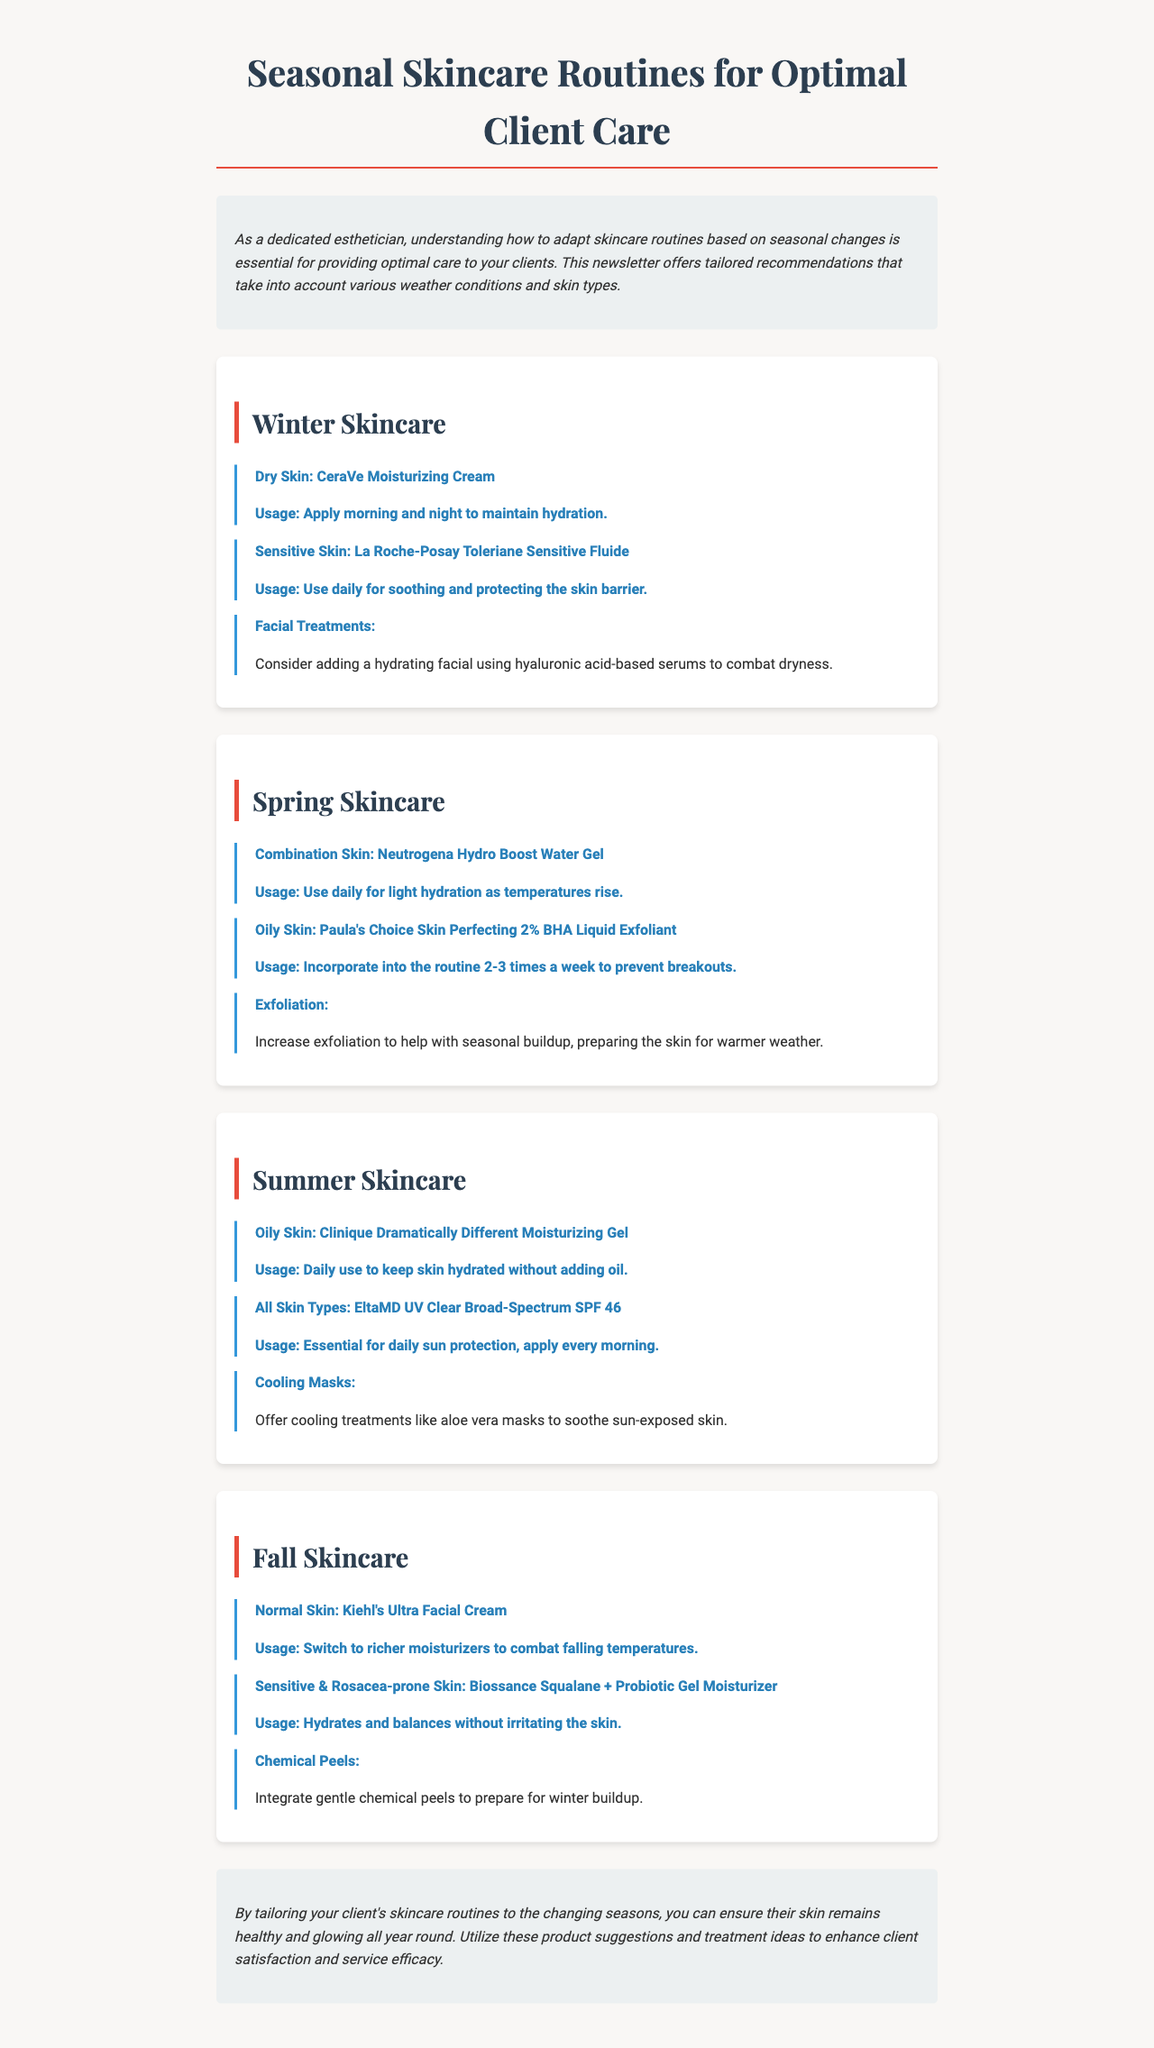What is the main focus of the newsletter? The newsletter focuses on adapting skincare routines based on seasonal changes for optimal client care.
Answer: Adapting skincare routines What product is recommended for dry skin in winter? The product recommended for dry skin during winter is specifically mentioned in the document.
Answer: CeraVe Moisturizing Cream How often should Paula's Choice Skin Perfecting 2% BHA Liquid Exfoliant be used? The document states how frequently this product should be incorporated into the routine for oily skin in spring.
Answer: 2-3 times a week Which treatment is suggested for summer skincare? The newsletter provides a specific treatment suggestion for soothing sun-exposed skin in summer.
Answer: Cooling Masks What moisturizer is recommended for normal skin in fall? The recommended moisturizer for normal skin during fall is stated in the seasonal skincare section of the newsletter.
Answer: Kiehl's Ultra Facial Cream Which skin type benefits from La Roche-Posay Toleriane Sensitive Fluide in winter? The document specifies the skin type that this product is tailored for during winter months.
Answer: Sensitive Skin What is a key feature of EltaMD UV Clear Broad-Spectrum SPF 46? This product is essential for daily use for sun protection during summer, as indicated in the newsletter.
Answer: Daily sun protection What skincare adjustment is recommended for all skin types in summer? The newsletter highlights a universal recommendation regarding applied sunscreen for all skin types.
Answer: Essential for daily sun protection 